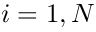<formula> <loc_0><loc_0><loc_500><loc_500>i = 1 , N</formula> 